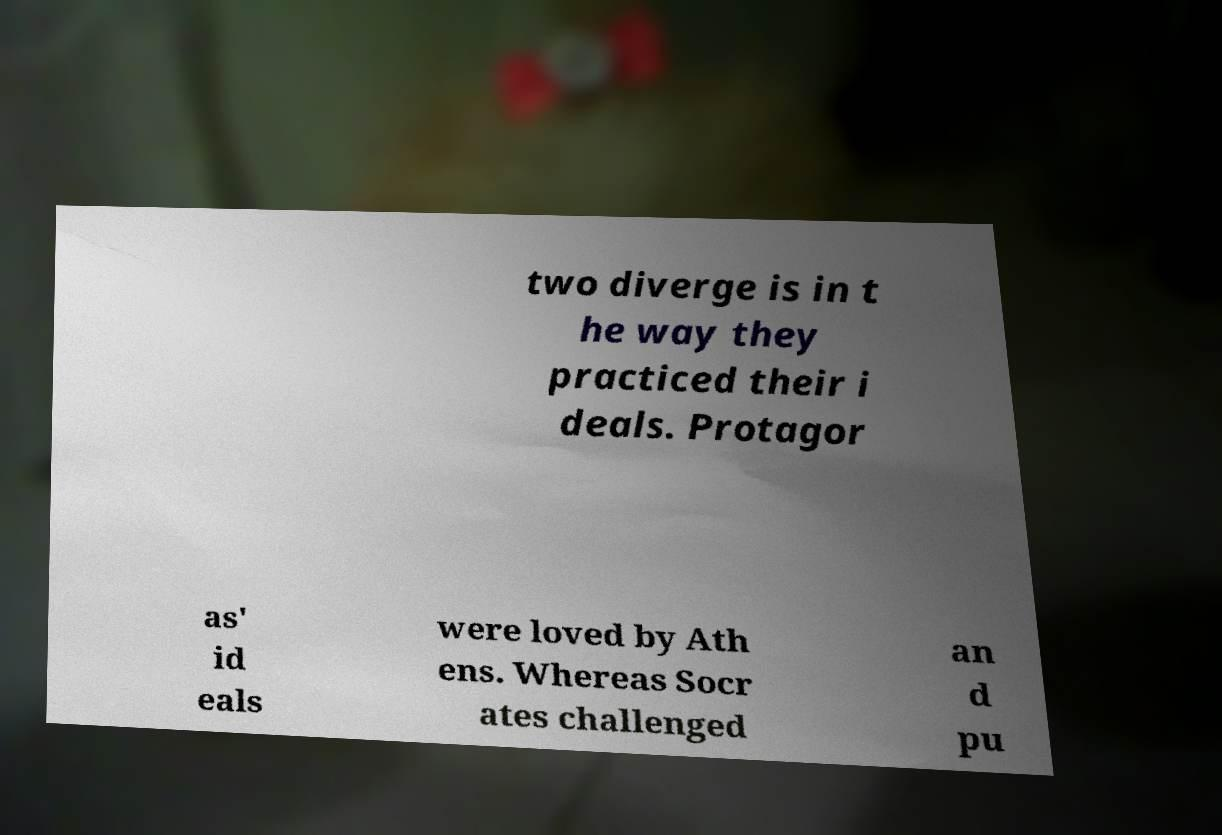Can you accurately transcribe the text from the provided image for me? two diverge is in t he way they practiced their i deals. Protagor as' id eals were loved by Ath ens. Whereas Socr ates challenged an d pu 